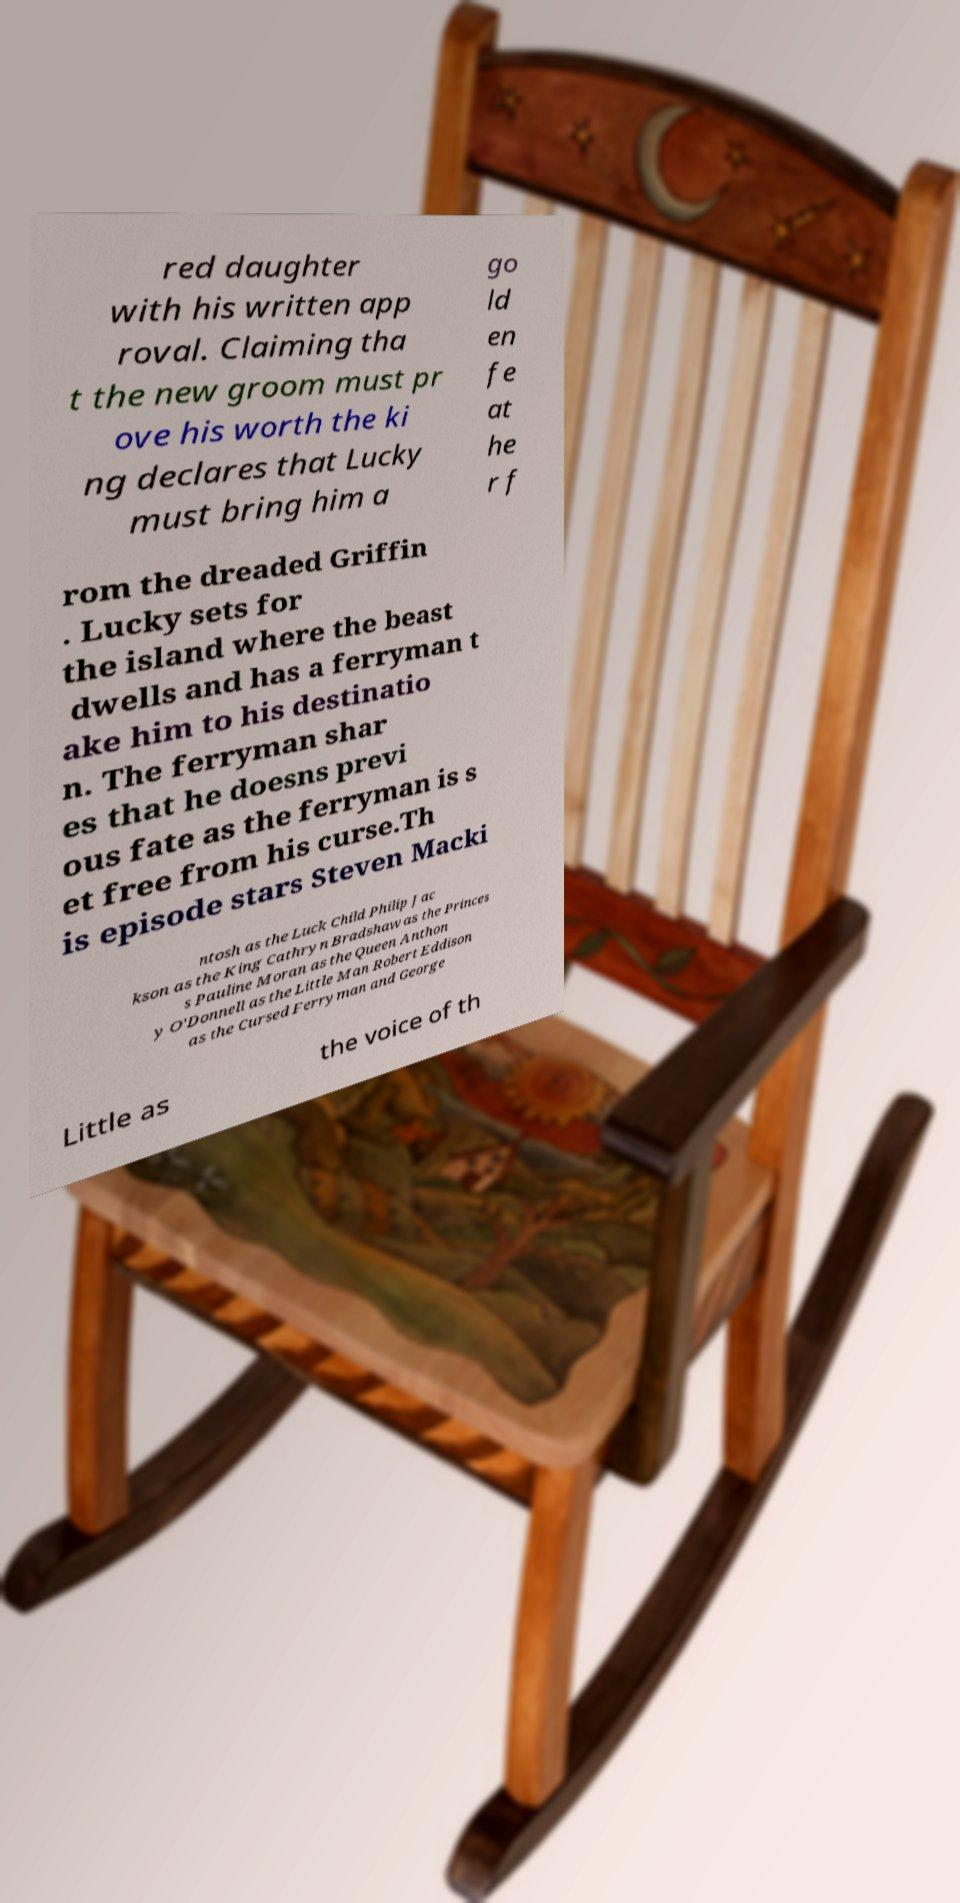Please identify and transcribe the text found in this image. red daughter with his written app roval. Claiming tha t the new groom must pr ove his worth the ki ng declares that Lucky must bring him a go ld en fe at he r f rom the dreaded Griffin . Lucky sets for the island where the beast dwells and has a ferryman t ake him to his destinatio n. The ferryman shar es that he doesns previ ous fate as the ferryman is s et free from his curse.Th is episode stars Steven Macki ntosh as the Luck Child Philip Jac kson as the King Cathryn Bradshaw as the Princes s Pauline Moran as the Queen Anthon y O'Donnell as the Little Man Robert Eddison as the Cursed Ferryman and George Little as the voice of th 